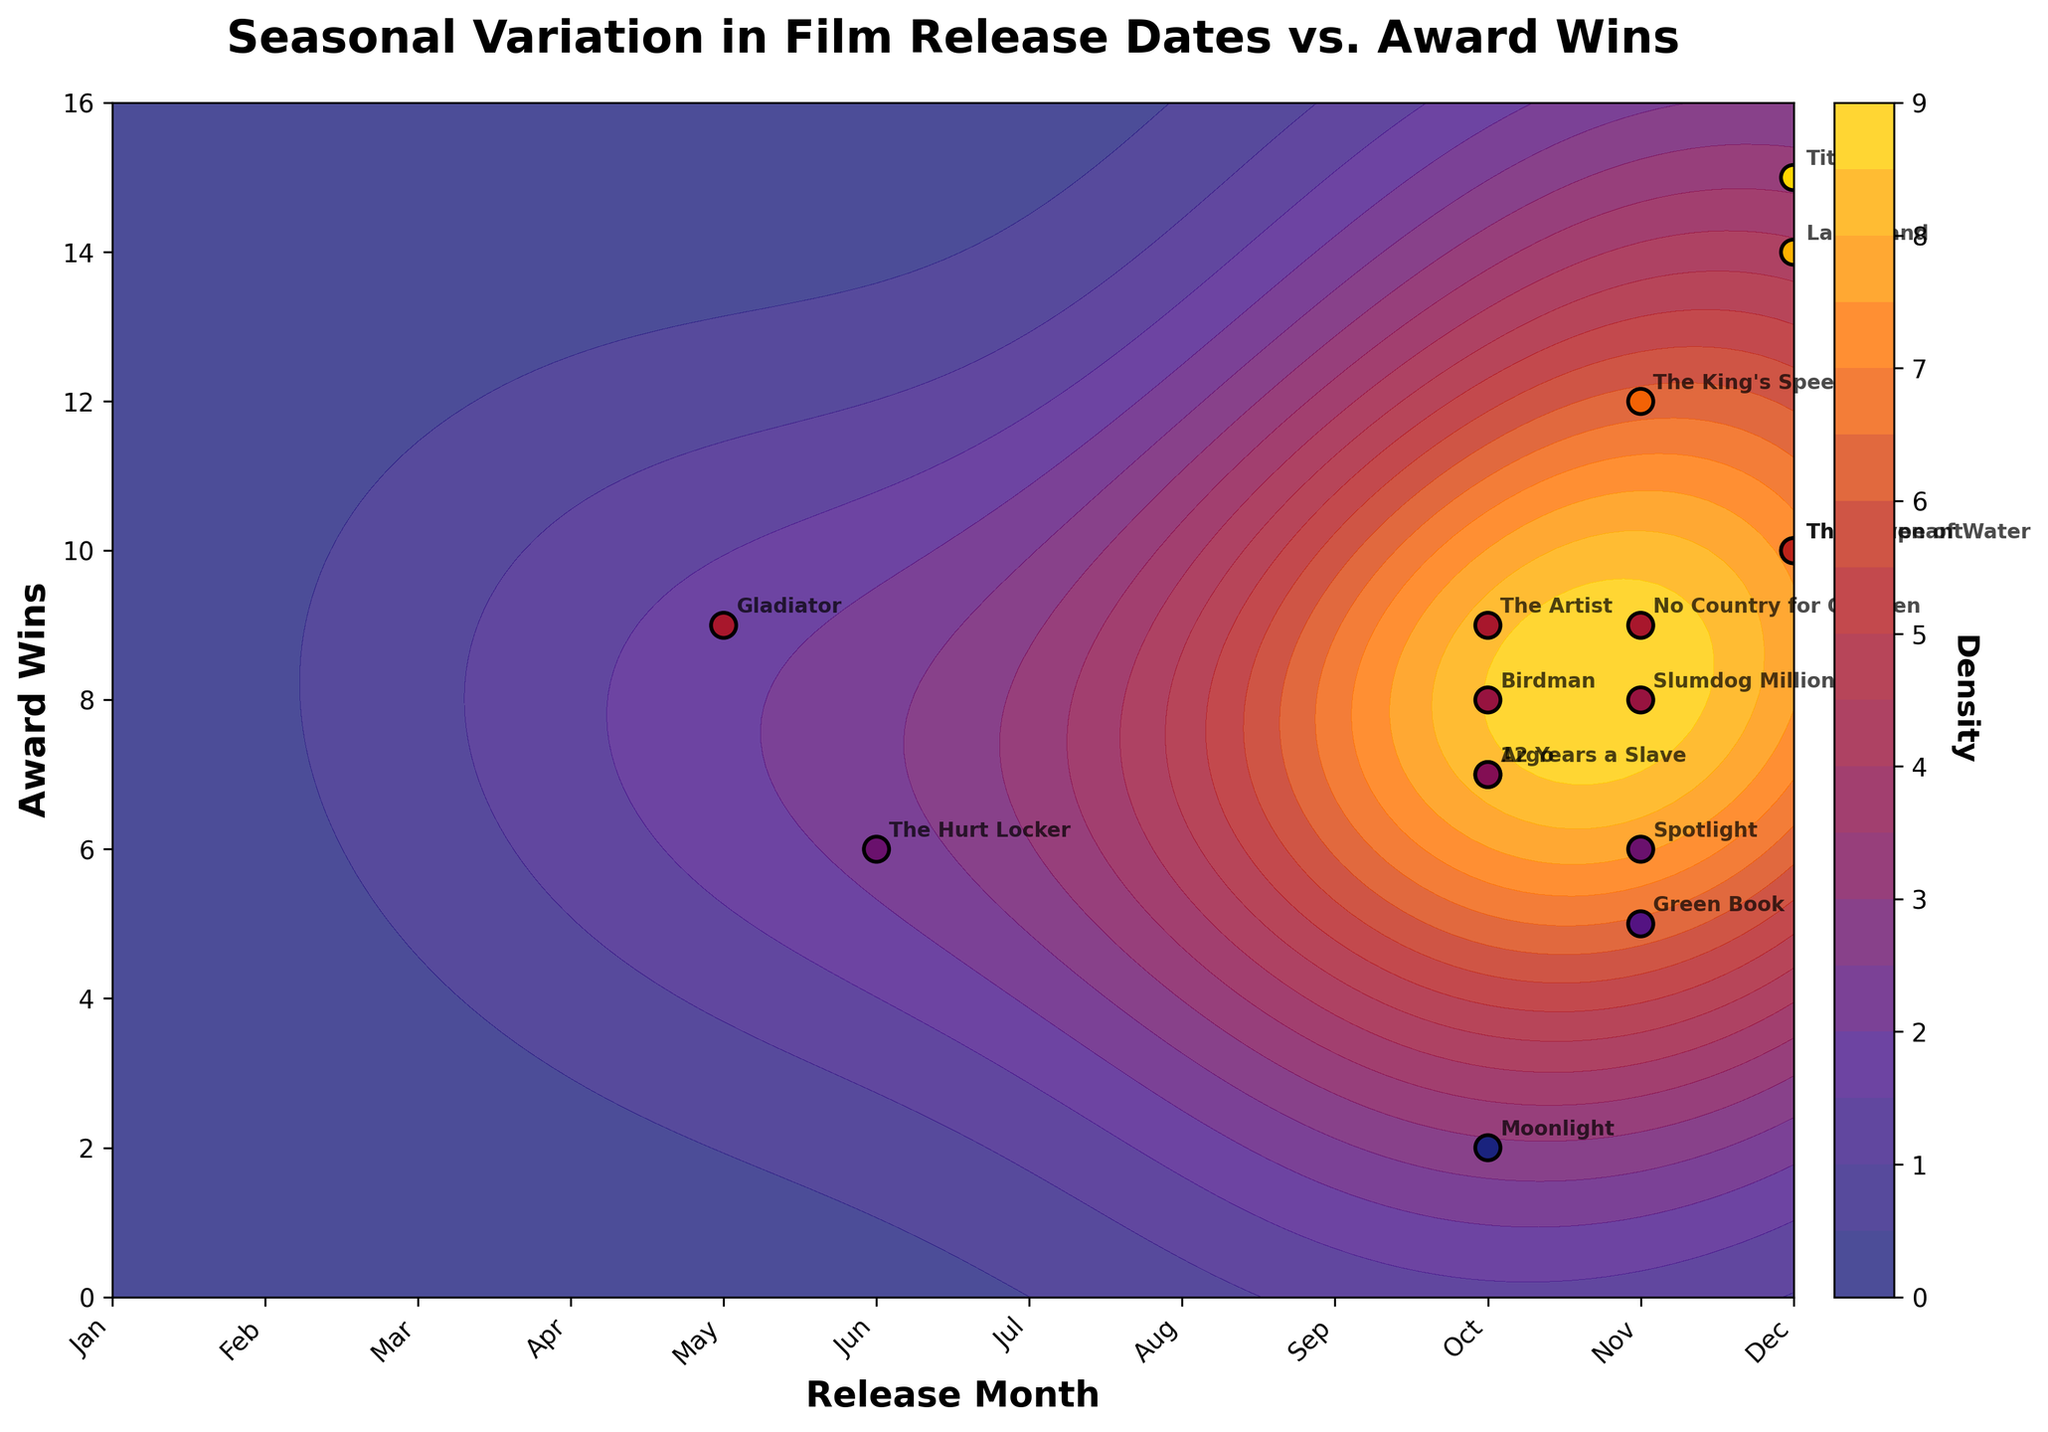What is the title of the figure? The title is usually placed at the top of the figure and is typically bold and larger than other text. In this case, it reads "Seasonal Variation in Film Release Dates vs. Award Wins".
Answer: Seasonal Variation in Film Release Dates vs. Award Wins How many months are considered in the figure? The x-axis represents the months, and there are 12 ticks labeled from January to December.
Answer: 12 What are the months with the highest number of award wins? By observing the scatter plot and checking the data points with the highest values on the y-axis, December stands out with movies like Titanic and La La Land that have high award wins.
Answer: December What is the range of Award Wins shown in the figure? The y-axis ranges from 0 to 16, indicating the award wins span this interval.
Answer: 0 to 16 Which month has movies with 10 or more award wins? Checking the scatter plot, December stands out with The Shape of Water, La La Land, The Revenant, and Titanic all winning 10 or more awards.
Answer: December How many films released in November won more than 5 awards? Analyze the November scatter points and count those above 5 on the y-axis: The King's Speech, Spotlight, Green Book, Slumdog Millionaire, No Country for Old Men.
Answer: 5 Which month has the least number of award wins for the films considered? By checking the scatter plot at each month, June has only one film (The Hurt Locker) with 6 awards, followed by May with Gladiator having 9 awards, and July, August, and July having no points.
Answer: June Are there any months with no film releases? There are no scatter points in the months January, February, March, April, July, and August indicating no films were released in these months in the dataset.
Answer: Yes Do films released closer to the end of the year tend to win more awards compared to those released earlier? Observing the density of scatter points and their award wins from October to December consistently shows higher wins, compared to other months like June and May.
Answer: Yes Is there a noticeable density concentration in any month? The contour plot shows a higher density concentration around the months of October, November, and December, indicating more film releases and possibly higher awards.
Answer: Yes, October to December 